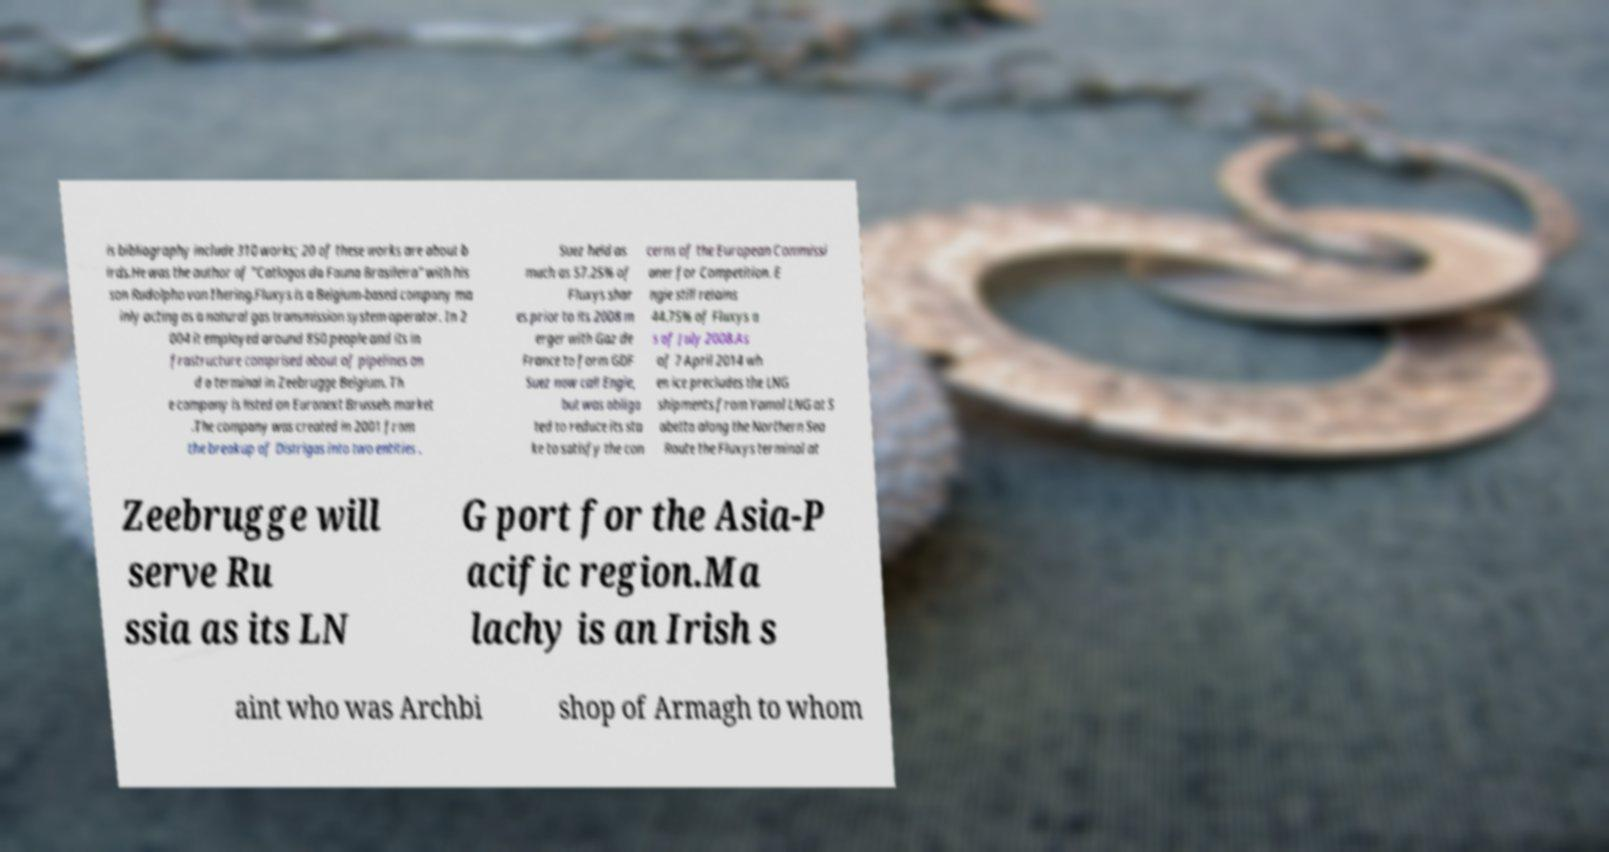Please read and relay the text visible in this image. What does it say? is bibliography include 310 works; 20 of these works are about b irds.He was the author of "Catlogos da Fauna Brasileira" with his son Rudolpho von Ihering.Fluxys is a Belgium-based company ma inly acting as a natural gas transmission system operator. In 2 004 it employed around 850 people and its in frastructure comprised about of pipelines an d a terminal in Zeebrugge Belgium. Th e company is listed on Euronext Brussels market .The company was created in 2001 from the breakup of Distrigas into two entities . Suez held as much as 57.25% of Fluxys shar es prior to its 2008 m erger with Gaz de France to form GDF Suez now call Engie, but was obliga ted to reduce its sta ke to satisfy the con cerns of the European Commissi oner for Competition. E ngie still retains 44.75% of Fluxys a s of July 2008.As of 7 April 2014 wh en ice precludes the LNG shipments from Yamal LNG at S abetta along the Northern Sea Route the Fluxys terminal at Zeebrugge will serve Ru ssia as its LN G port for the Asia-P acific region.Ma lachy is an Irish s aint who was Archbi shop of Armagh to whom 